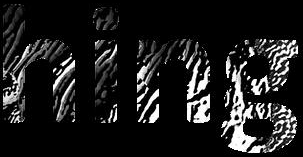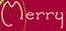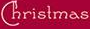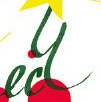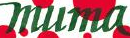Transcribe the words shown in these images in order, separated by a semicolon. hing; Merry; Christmas; ecy; muma 